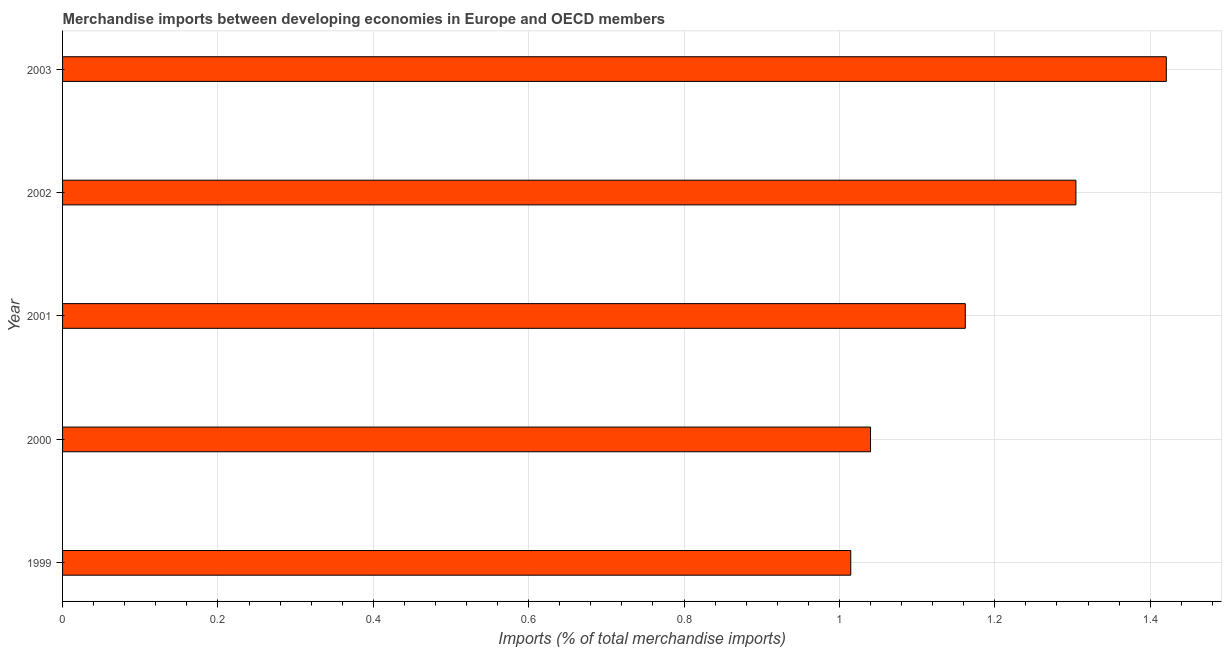Does the graph contain any zero values?
Give a very brief answer. No. What is the title of the graph?
Provide a succinct answer. Merchandise imports between developing economies in Europe and OECD members. What is the label or title of the X-axis?
Make the answer very short. Imports (% of total merchandise imports). What is the merchandise imports in 2003?
Ensure brevity in your answer.  1.42. Across all years, what is the maximum merchandise imports?
Offer a terse response. 1.42. Across all years, what is the minimum merchandise imports?
Your response must be concise. 1.01. What is the sum of the merchandise imports?
Provide a succinct answer. 5.94. What is the difference between the merchandise imports in 2001 and 2003?
Make the answer very short. -0.26. What is the average merchandise imports per year?
Ensure brevity in your answer.  1.19. What is the median merchandise imports?
Your answer should be compact. 1.16. In how many years, is the merchandise imports greater than 0.88 %?
Offer a very short reply. 5. What is the ratio of the merchandise imports in 2000 to that in 2003?
Give a very brief answer. 0.73. Is the merchandise imports in 2000 less than that in 2002?
Your answer should be compact. Yes. What is the difference between the highest and the second highest merchandise imports?
Offer a very short reply. 0.12. What is the difference between the highest and the lowest merchandise imports?
Keep it short and to the point. 0.41. In how many years, is the merchandise imports greater than the average merchandise imports taken over all years?
Your answer should be compact. 2. Are all the bars in the graph horizontal?
Your response must be concise. Yes. Are the values on the major ticks of X-axis written in scientific E-notation?
Provide a succinct answer. No. What is the Imports (% of total merchandise imports) of 1999?
Provide a short and direct response. 1.01. What is the Imports (% of total merchandise imports) of 2000?
Provide a short and direct response. 1.04. What is the Imports (% of total merchandise imports) in 2001?
Provide a short and direct response. 1.16. What is the Imports (% of total merchandise imports) in 2002?
Ensure brevity in your answer.  1.3. What is the Imports (% of total merchandise imports) in 2003?
Ensure brevity in your answer.  1.42. What is the difference between the Imports (% of total merchandise imports) in 1999 and 2000?
Make the answer very short. -0.03. What is the difference between the Imports (% of total merchandise imports) in 1999 and 2001?
Make the answer very short. -0.15. What is the difference between the Imports (% of total merchandise imports) in 1999 and 2002?
Ensure brevity in your answer.  -0.29. What is the difference between the Imports (% of total merchandise imports) in 1999 and 2003?
Offer a very short reply. -0.41. What is the difference between the Imports (% of total merchandise imports) in 2000 and 2001?
Provide a succinct answer. -0.12. What is the difference between the Imports (% of total merchandise imports) in 2000 and 2002?
Provide a succinct answer. -0.26. What is the difference between the Imports (% of total merchandise imports) in 2000 and 2003?
Provide a succinct answer. -0.38. What is the difference between the Imports (% of total merchandise imports) in 2001 and 2002?
Make the answer very short. -0.14. What is the difference between the Imports (% of total merchandise imports) in 2001 and 2003?
Offer a terse response. -0.26. What is the difference between the Imports (% of total merchandise imports) in 2002 and 2003?
Offer a terse response. -0.12. What is the ratio of the Imports (% of total merchandise imports) in 1999 to that in 2001?
Give a very brief answer. 0.87. What is the ratio of the Imports (% of total merchandise imports) in 1999 to that in 2002?
Your response must be concise. 0.78. What is the ratio of the Imports (% of total merchandise imports) in 1999 to that in 2003?
Offer a terse response. 0.71. What is the ratio of the Imports (% of total merchandise imports) in 2000 to that in 2001?
Provide a short and direct response. 0.9. What is the ratio of the Imports (% of total merchandise imports) in 2000 to that in 2002?
Ensure brevity in your answer.  0.8. What is the ratio of the Imports (% of total merchandise imports) in 2000 to that in 2003?
Provide a short and direct response. 0.73. What is the ratio of the Imports (% of total merchandise imports) in 2001 to that in 2002?
Offer a terse response. 0.89. What is the ratio of the Imports (% of total merchandise imports) in 2001 to that in 2003?
Your answer should be very brief. 0.82. What is the ratio of the Imports (% of total merchandise imports) in 2002 to that in 2003?
Your answer should be very brief. 0.92. 